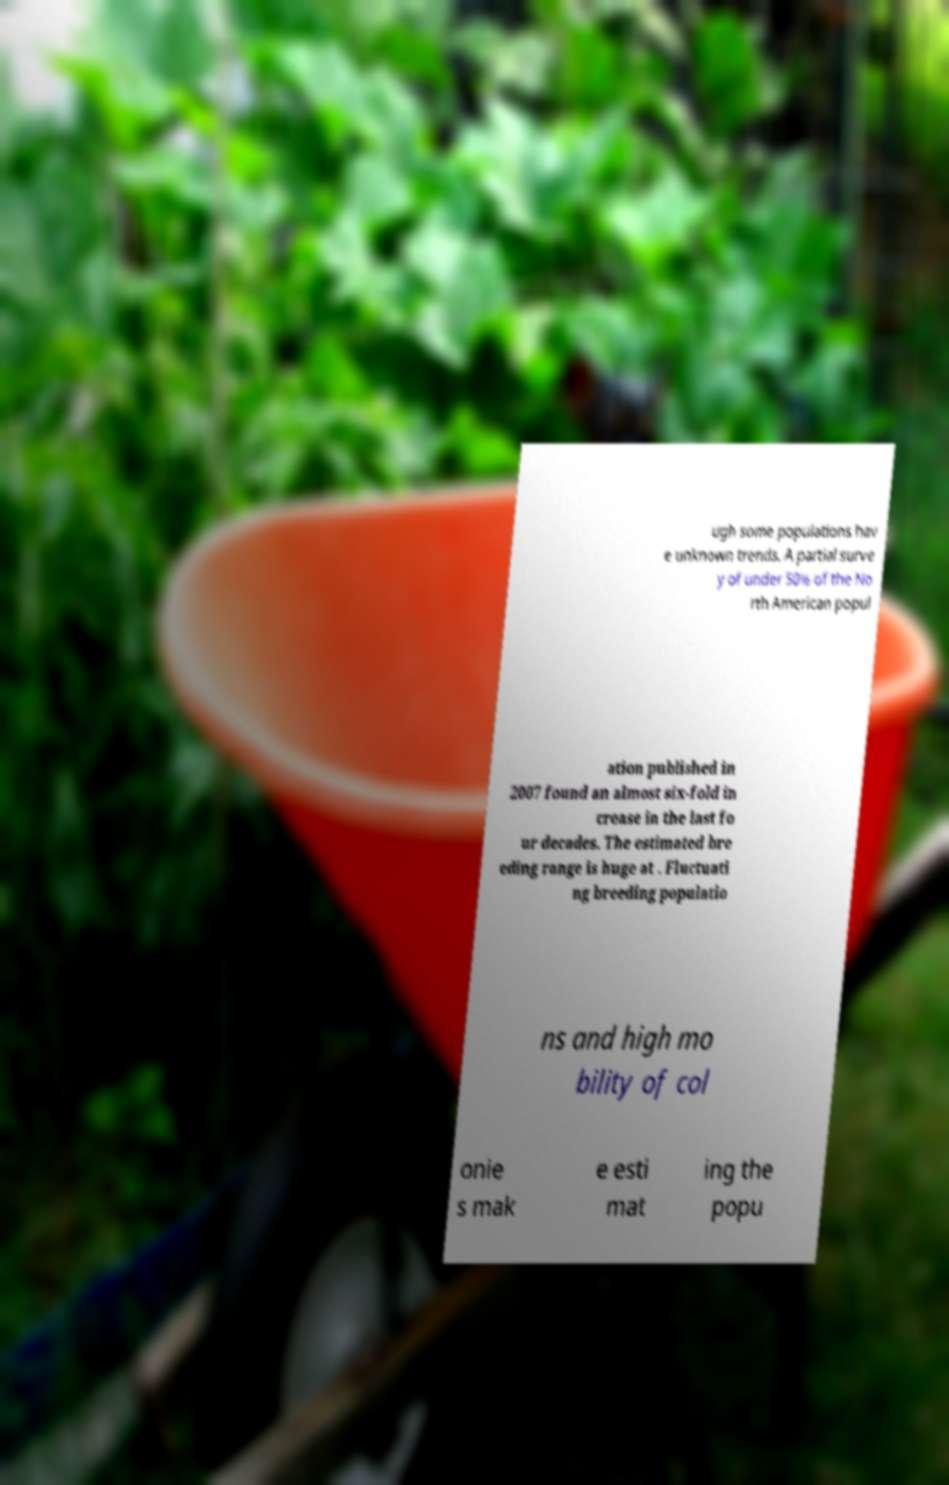What messages or text are displayed in this image? I need them in a readable, typed format. ugh some populations hav e unknown trends. A partial surve y of under 50% of the No rth American popul ation published in 2007 found an almost six-fold in crease in the last fo ur decades. The estimated bre eding range is huge at . Fluctuati ng breeding populatio ns and high mo bility of col onie s mak e esti mat ing the popu 